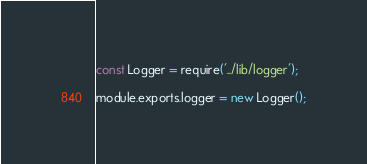Convert code to text. <code><loc_0><loc_0><loc_500><loc_500><_JavaScript_>const Logger = require('../lib/logger');

module.exports.logger = new Logger();
</code> 